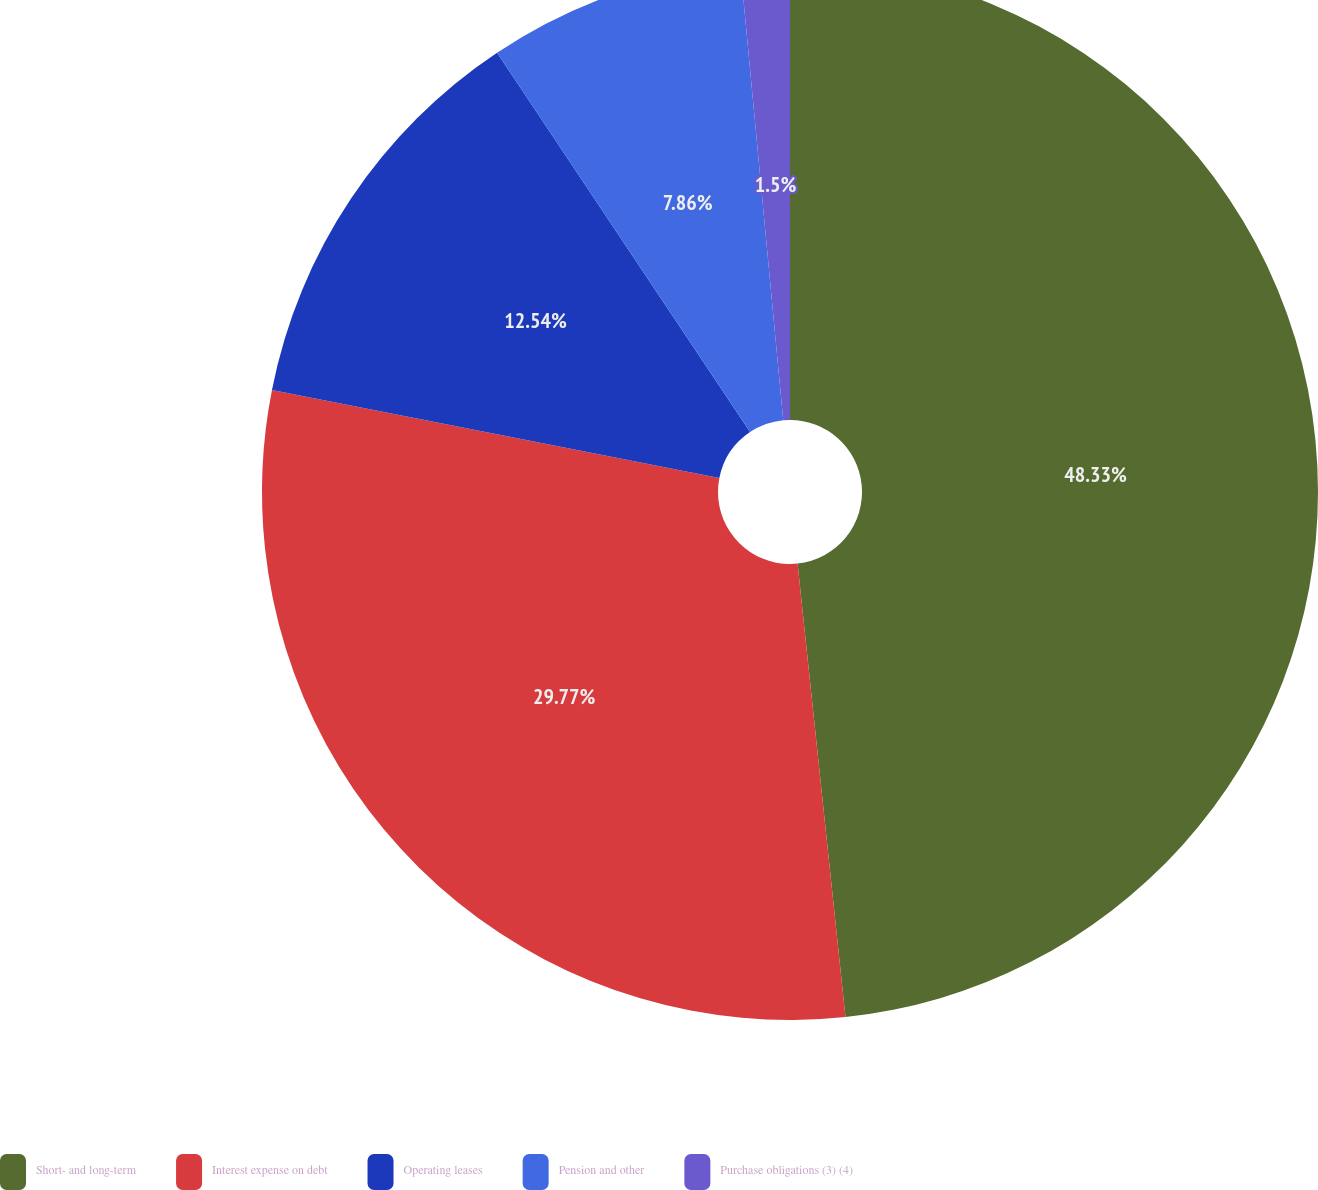<chart> <loc_0><loc_0><loc_500><loc_500><pie_chart><fcel>Short- and long-term<fcel>Interest expense on debt<fcel>Operating leases<fcel>Pension and other<fcel>Purchase obligations (3) (4)<nl><fcel>48.32%<fcel>29.77%<fcel>12.54%<fcel>7.86%<fcel>1.5%<nl></chart> 